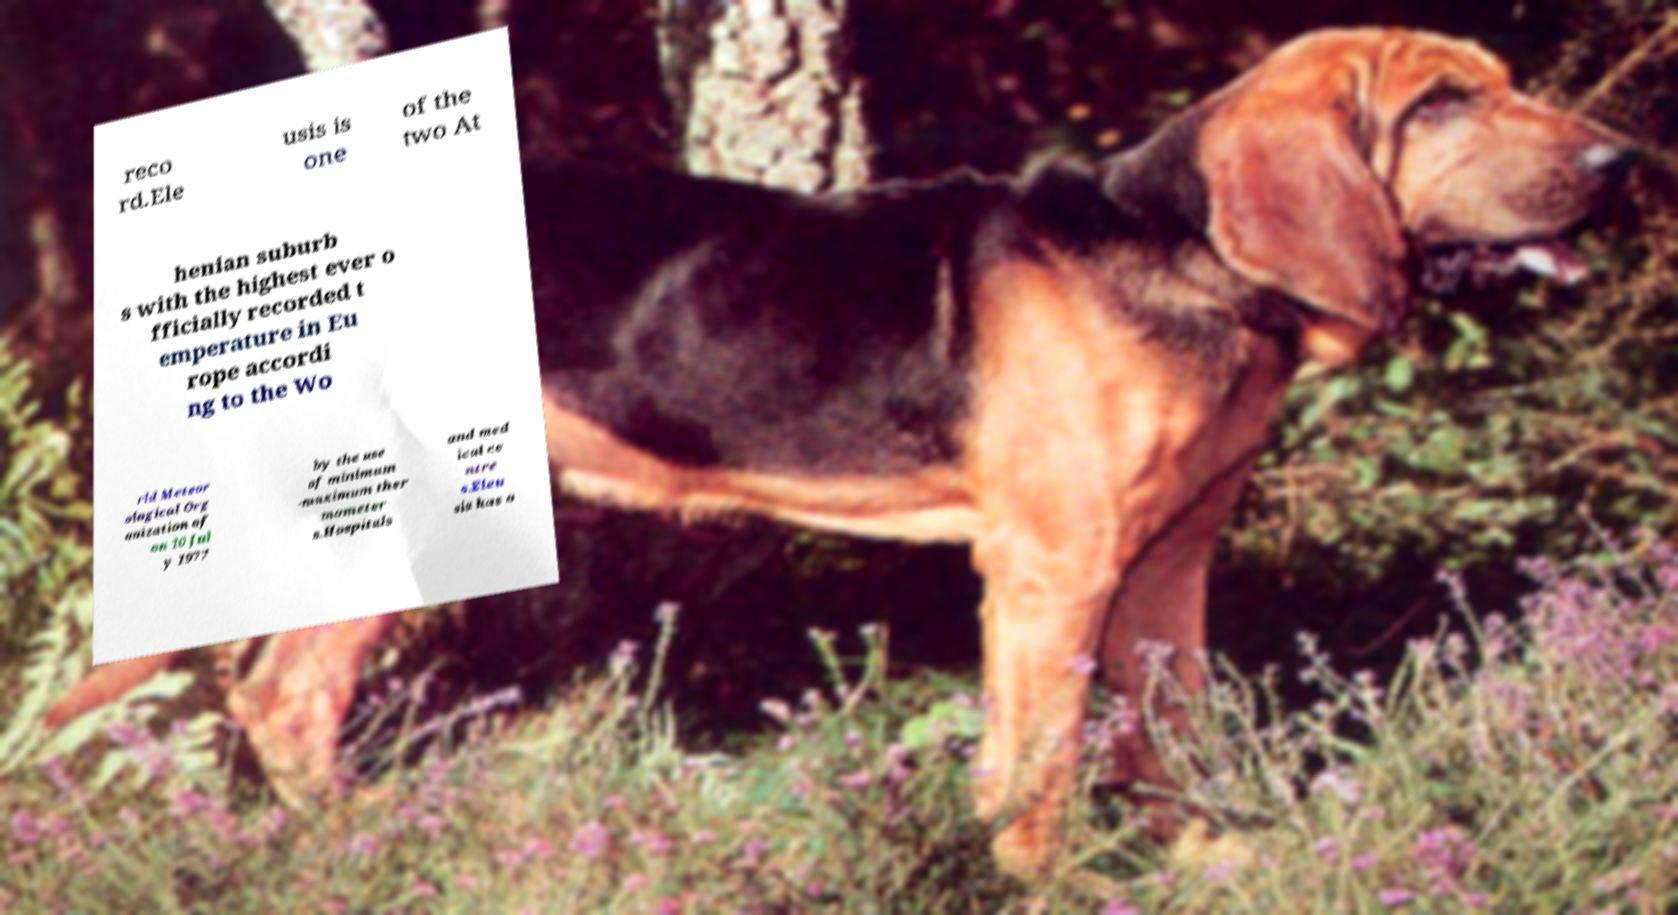Could you extract and type out the text from this image? reco rd.Ele usis is one of the two At henian suburb s with the highest ever o fficially recorded t emperature in Eu rope accordi ng to the Wo rld Meteor ological Org anization of on 10 Jul y 1977 by the use of minimum -maximum ther mometer s.Hospitals and med ical ce ntre s.Eleu sis has o 